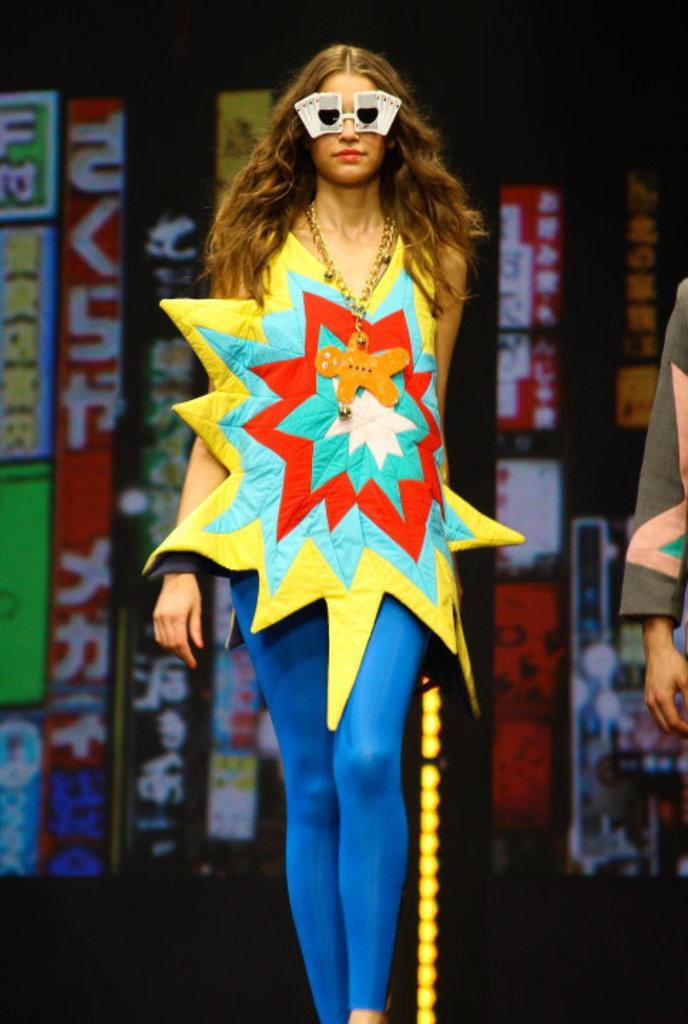Who is the main subject in the image? There is a lady in the image. What is the lady wearing on her face? The lady is wearing goggles. What is the lady doing in the image? The lady is walking. What can be seen in the background of the image? There are banners in the background of the image. Can you see any deer in the image? No, there are no deer present in the image. What type of coastline can be seen in the image? There is no coastline visible in the image. 